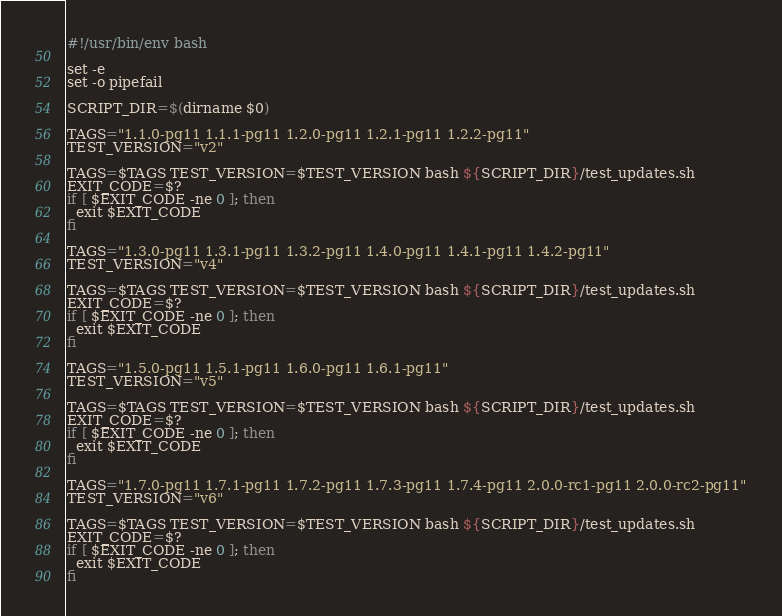<code> <loc_0><loc_0><loc_500><loc_500><_Bash_>#!/usr/bin/env bash

set -e
set -o pipefail

SCRIPT_DIR=$(dirname $0)

TAGS="1.1.0-pg11 1.1.1-pg11 1.2.0-pg11 1.2.1-pg11 1.2.2-pg11"
TEST_VERSION="v2"

TAGS=$TAGS TEST_VERSION=$TEST_VERSION bash ${SCRIPT_DIR}/test_updates.sh
EXIT_CODE=$?
if [ $EXIT_CODE -ne 0 ]; then
  exit $EXIT_CODE
fi

TAGS="1.3.0-pg11 1.3.1-pg11 1.3.2-pg11 1.4.0-pg11 1.4.1-pg11 1.4.2-pg11"
TEST_VERSION="v4"

TAGS=$TAGS TEST_VERSION=$TEST_VERSION bash ${SCRIPT_DIR}/test_updates.sh
EXIT_CODE=$?
if [ $EXIT_CODE -ne 0 ]; then
  exit $EXIT_CODE
fi

TAGS="1.5.0-pg11 1.5.1-pg11 1.6.0-pg11 1.6.1-pg11"
TEST_VERSION="v5"

TAGS=$TAGS TEST_VERSION=$TEST_VERSION bash ${SCRIPT_DIR}/test_updates.sh
EXIT_CODE=$?
if [ $EXIT_CODE -ne 0 ]; then
  exit $EXIT_CODE
fi

TAGS="1.7.0-pg11 1.7.1-pg11 1.7.2-pg11 1.7.3-pg11 1.7.4-pg11 2.0.0-rc1-pg11 2.0.0-rc2-pg11"
TEST_VERSION="v6"

TAGS=$TAGS TEST_VERSION=$TEST_VERSION bash ${SCRIPT_DIR}/test_updates.sh
EXIT_CODE=$?
if [ $EXIT_CODE -ne 0 ]; then
  exit $EXIT_CODE
fi
</code> 